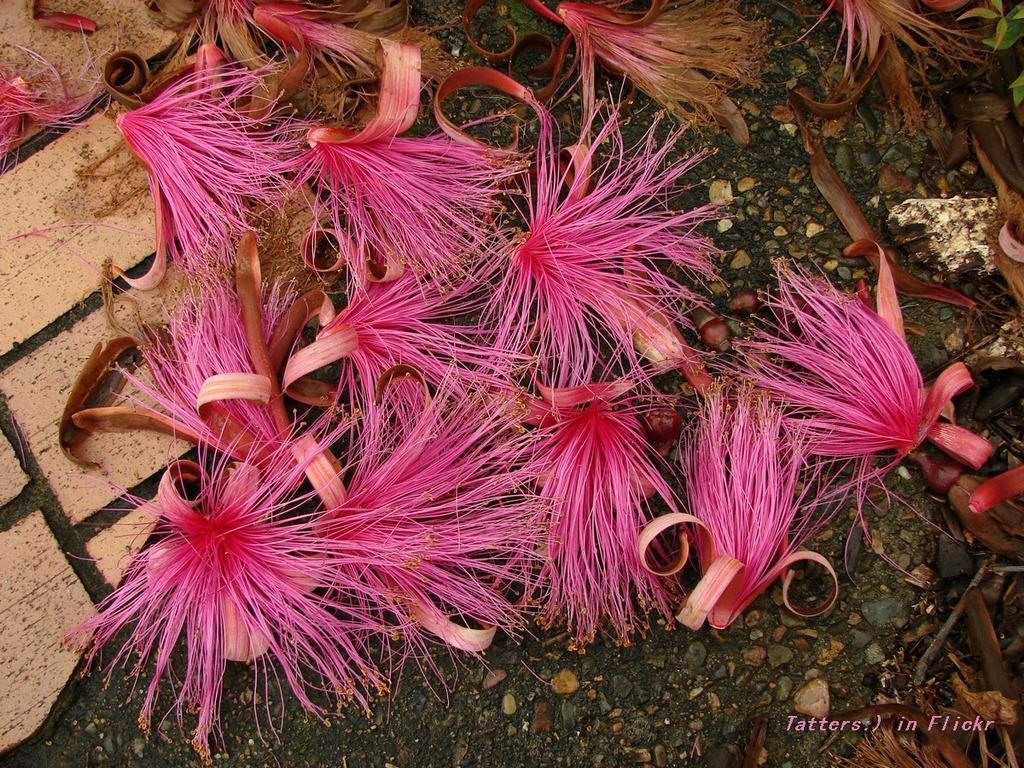Could you give a brief overview of what you see in this image? In this picture, we see the flowers in pink color. At the bottom, we see the soil and the stones. On the left side, we see the pavement. 